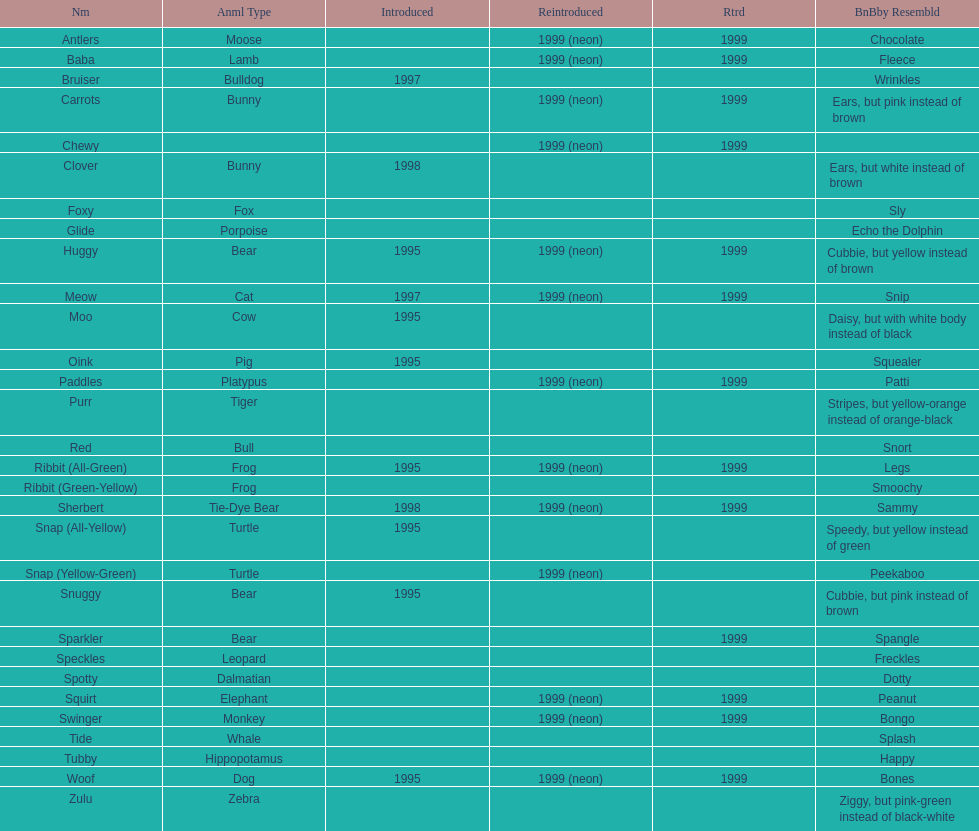What is the total number of pillow pals that were reintroduced as a neon variety? 13. 